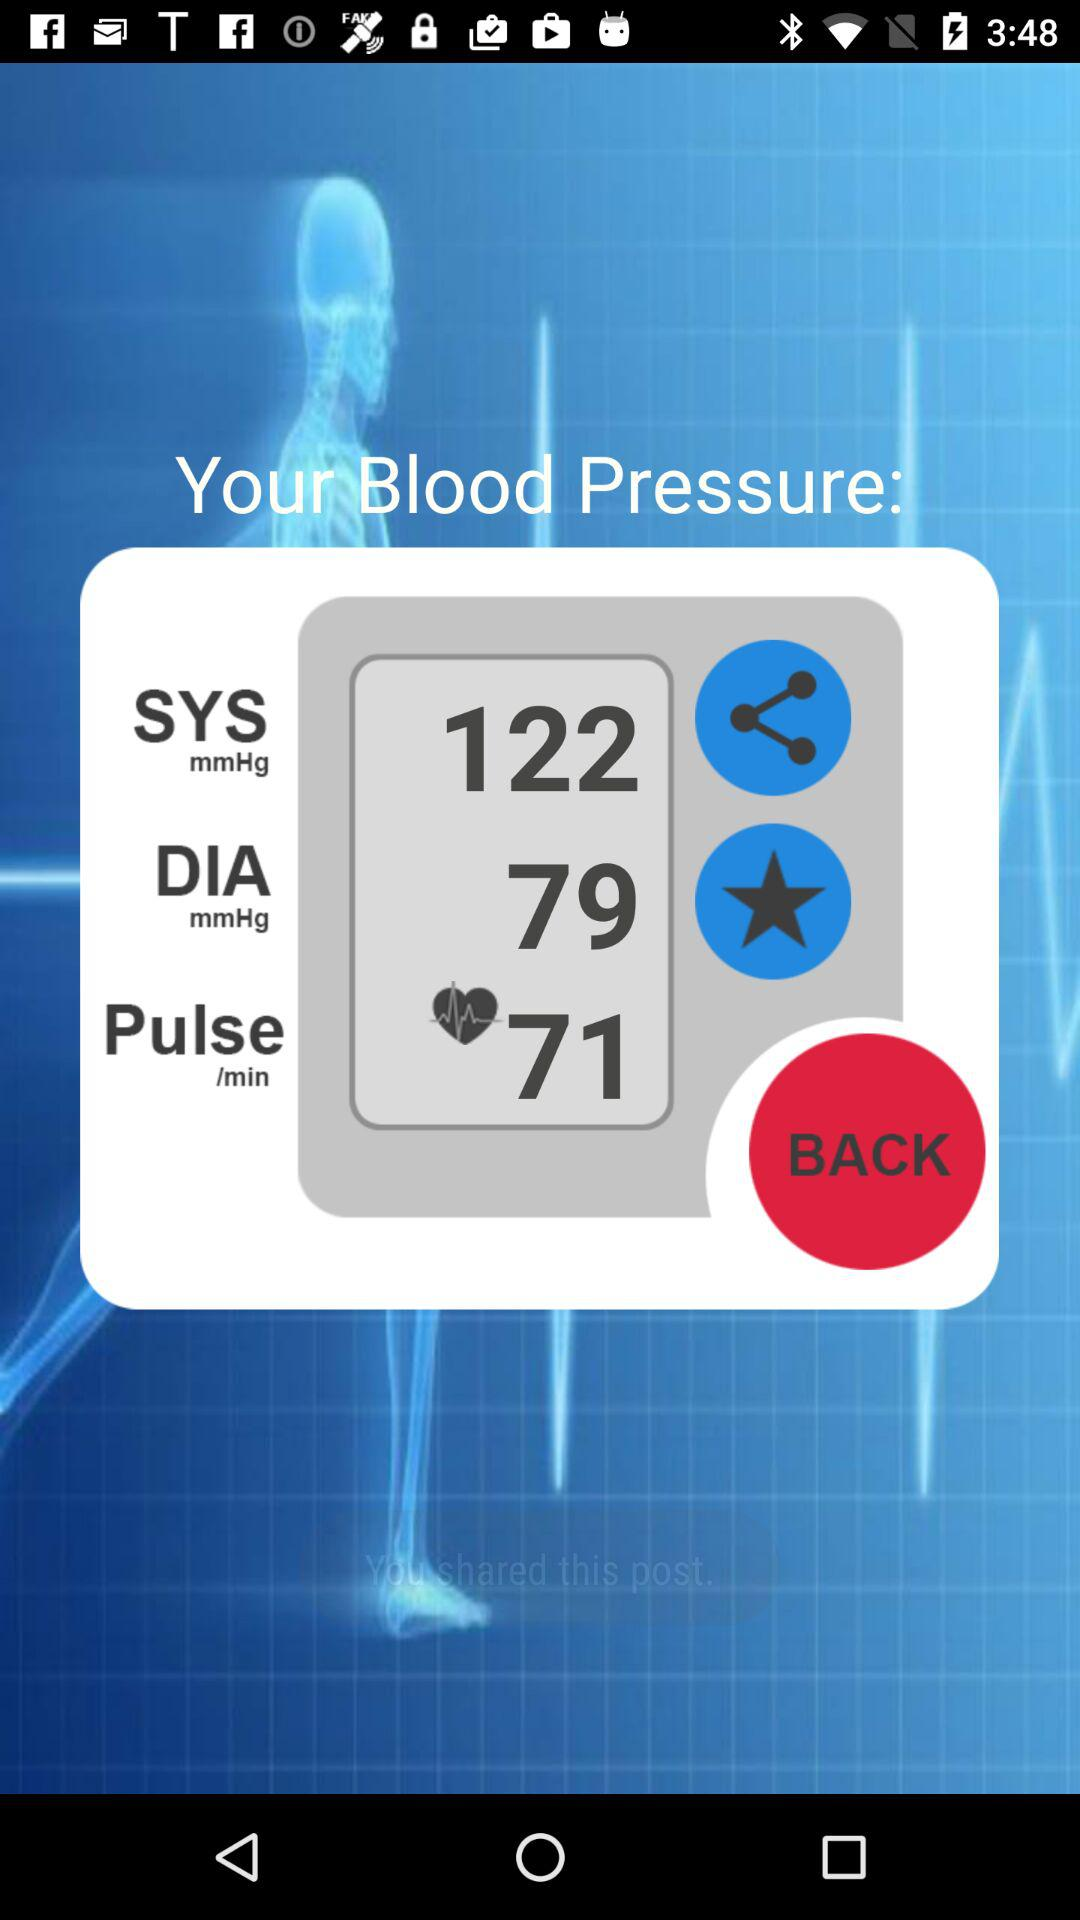What is the systolic blood pressure? The systolic blood pressure is 122 mmHg. 